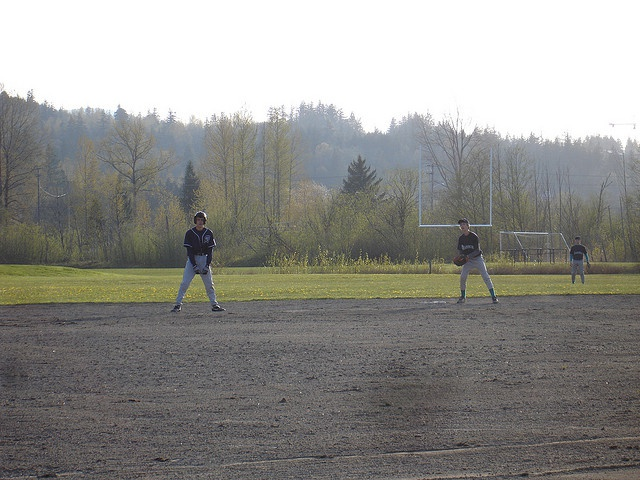Describe the objects in this image and their specific colors. I can see people in white, black, and gray tones, people in white, gray, black, and darkgray tones, people in white, gray, black, and blue tones, baseball glove in white, black, and gray tones, and baseball glove in white, gray, black, and blue tones in this image. 